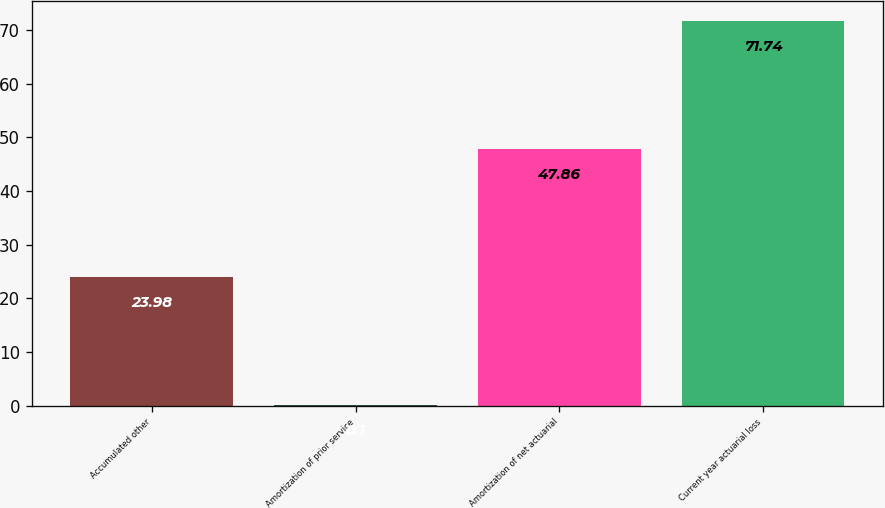Convert chart. <chart><loc_0><loc_0><loc_500><loc_500><bar_chart><fcel>Accumulated other<fcel>Amortization of prior service<fcel>Amortization of net actuarial<fcel>Current year actuarial loss<nl><fcel>23.98<fcel>0.1<fcel>47.86<fcel>71.74<nl></chart> 